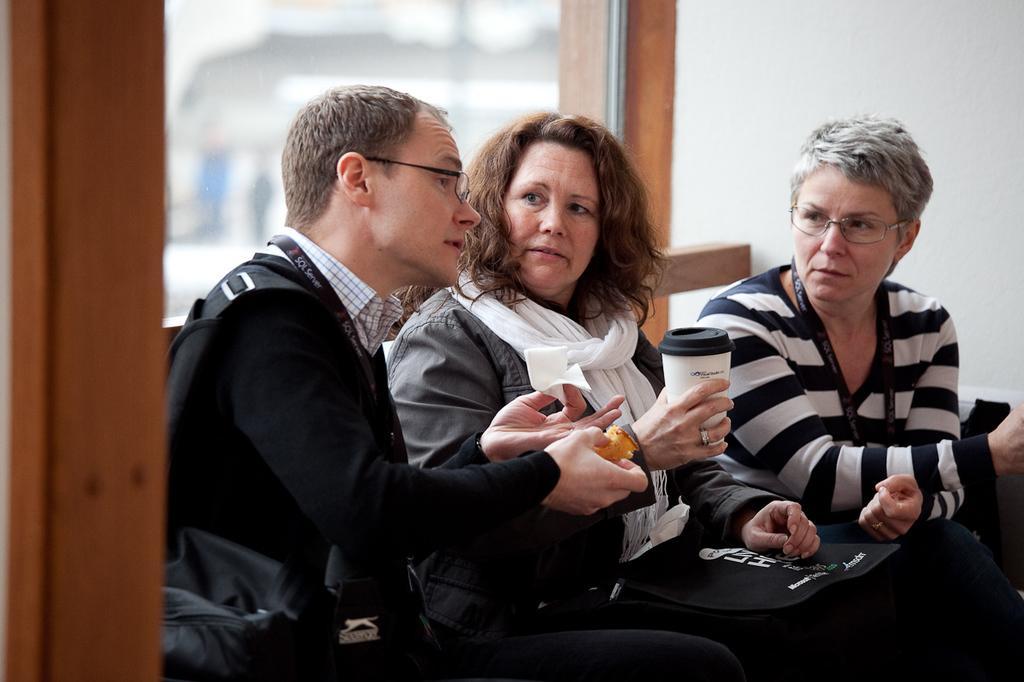Could you give a brief overview of what you see in this image? In this image, we can see people sitting and wearing id cards and holding some objects and in the background, there is a wall. 